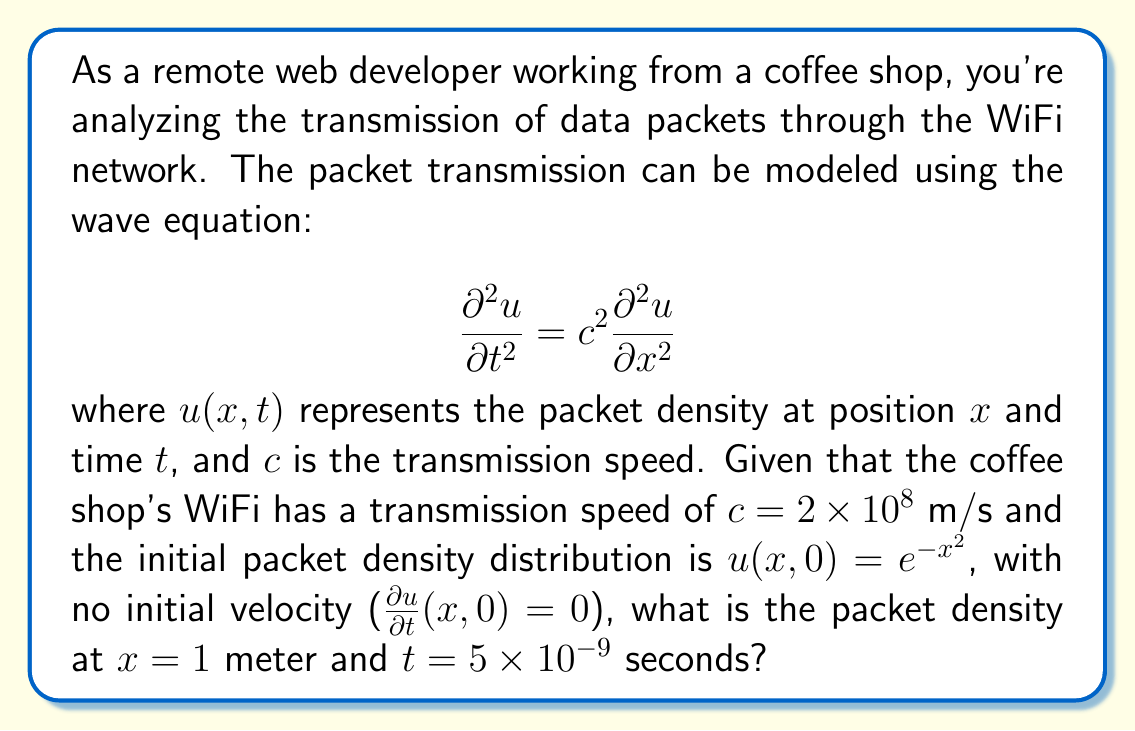Help me with this question. To solve this problem, we need to use D'Alembert's solution to the wave equation, which is given by:

$$u(x,t) = \frac{1}{2}[f(x+ct) + f(x-ct)] + \frac{1}{2c}\int_{x-ct}^{x+ct} g(s) ds$$

where $f(x) = u(x,0)$ is the initial displacement and $g(x) = u_t(x,0)$ is the initial velocity.

Given:
- $c = 2 \times 10^8$ m/s
- $f(x) = u(x,0) = e^{-x^2}$
- $g(x) = u_t(x,0) = 0$
- We need to find $u(1, 5 \times 10^{-9})$

Steps:
1) Since $g(x) = 0$, the integral term in D'Alembert's solution becomes zero. So our solution simplifies to:

   $$u(x,t) = \frac{1}{2}[f(x+ct) + f(x-ct)]$$

2) Calculate $ct$:
   
   $$ct = (2 \times 10^8)(5 \times 10^{-9}) = 1$$

3) Now, we need to evaluate:

   $$u(1, 5 \times 10^{-9}) = \frac{1}{2}[f(1+1) + f(1-1)] = \frac{1}{2}[f(2) + f(0)]$$

4) Evaluate $f(2)$ and $f(0)$:
   
   $$f(2) = e^{-2^2} = e^{-4}$$
   $$f(0) = e^{-0^2} = e^0 = 1$$

5) Substitute these values into our equation:

   $$u(1, 5 \times 10^{-9}) = \frac{1}{2}[e^{-4} + 1]$$

6) Simplify:

   $$u(1, 5 \times 10^{-9}) = \frac{1 + e^{-4}}{2}$$

This is our final answer.
Answer: $\frac{1 + e^{-4}}{2}$ 